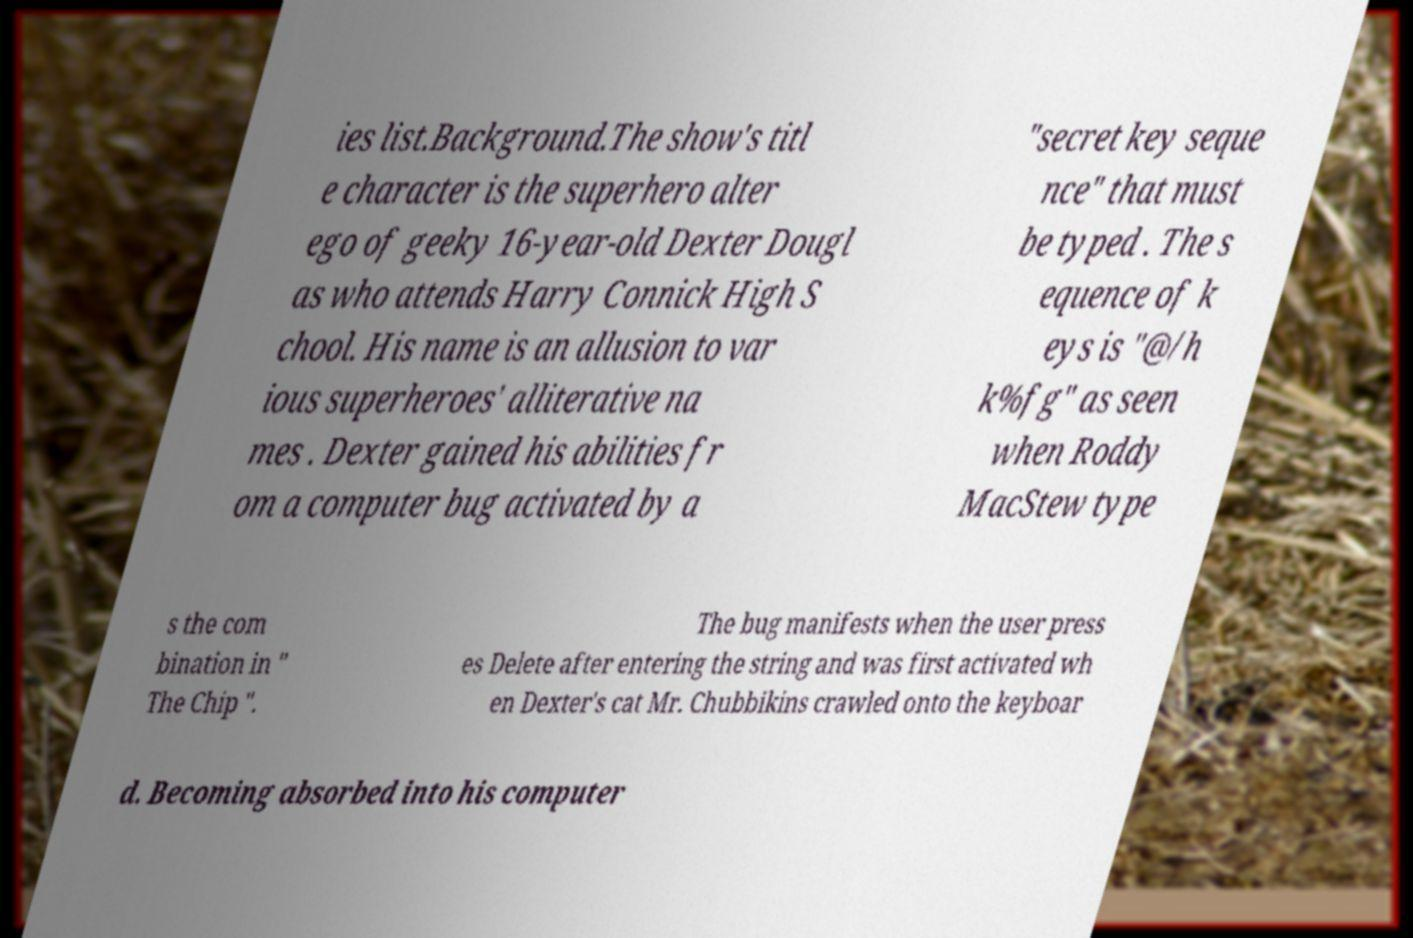Can you read and provide the text displayed in the image?This photo seems to have some interesting text. Can you extract and type it out for me? ies list.Background.The show's titl e character is the superhero alter ego of geeky 16-year-old Dexter Dougl as who attends Harry Connick High S chool. His name is an allusion to var ious superheroes' alliterative na mes . Dexter gained his abilities fr om a computer bug activated by a "secret key seque nce" that must be typed . The s equence of k eys is "@/h k%fg" as seen when Roddy MacStew type s the com bination in " The Chip ". The bug manifests when the user press es Delete after entering the string and was first activated wh en Dexter's cat Mr. Chubbikins crawled onto the keyboar d. Becoming absorbed into his computer 